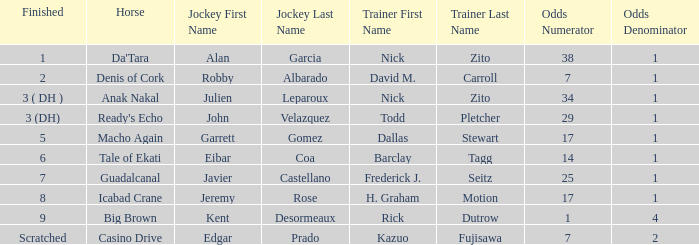Who is the Jockey that has Nick Zito as Trainer and Odds of 34-1? Julien Leparoux. 